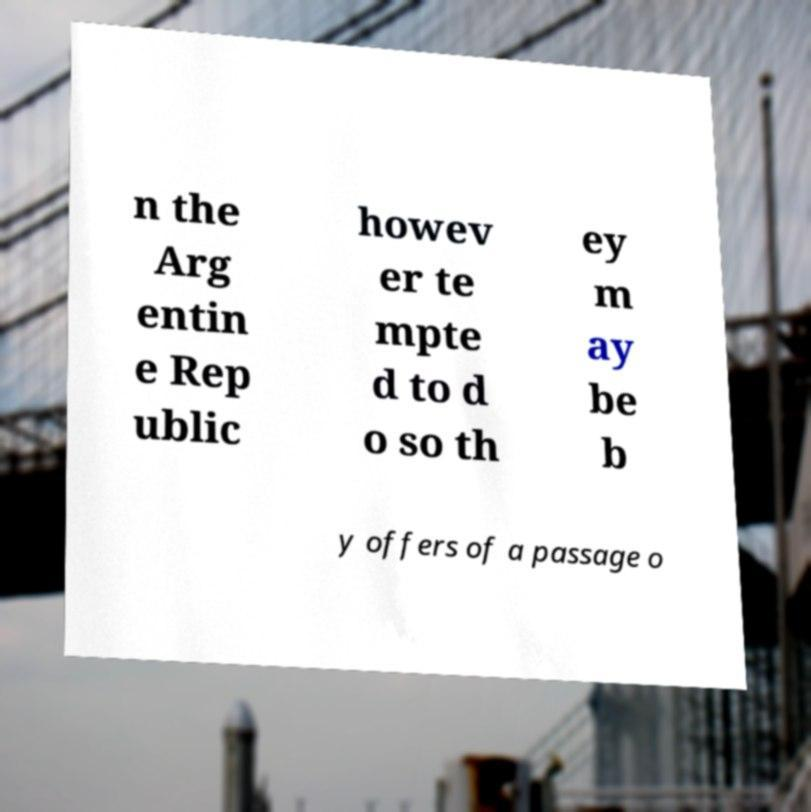There's text embedded in this image that I need extracted. Can you transcribe it verbatim? n the Arg entin e Rep ublic howev er te mpte d to d o so th ey m ay be b y offers of a passage o 